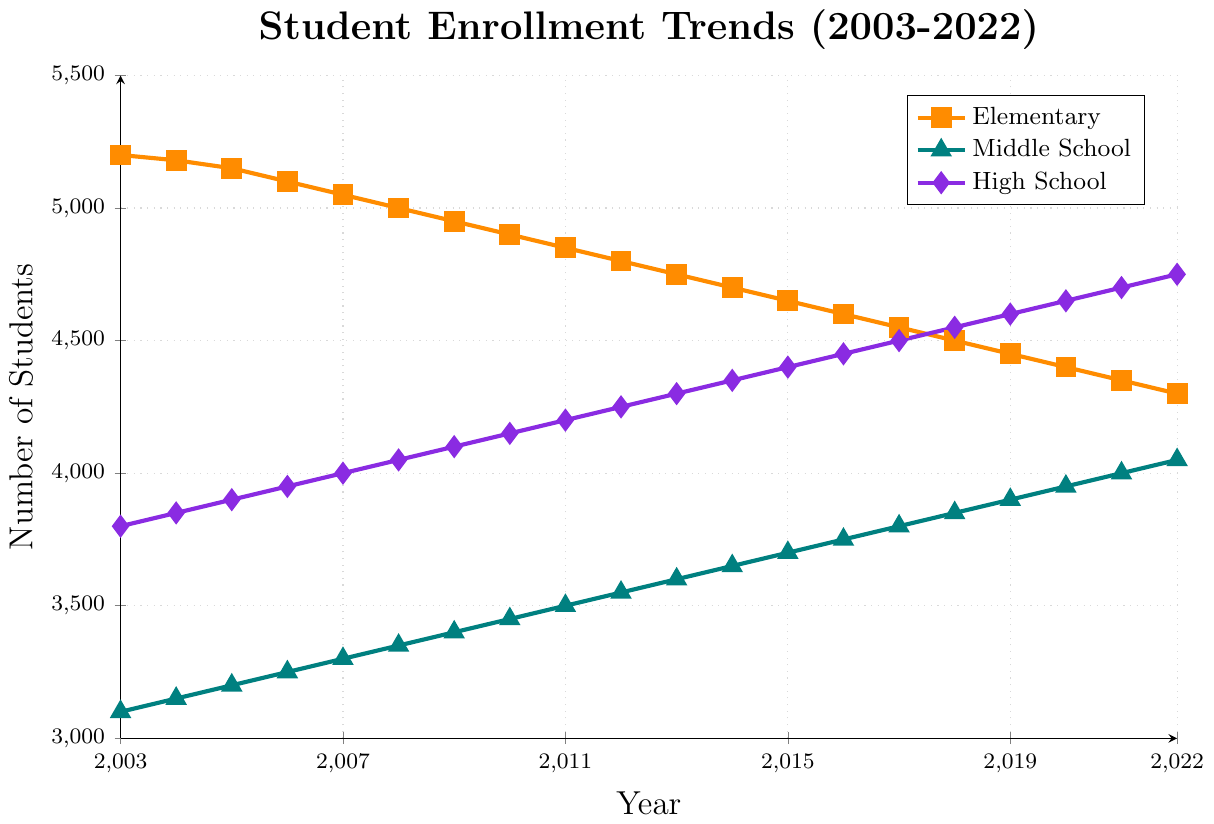What is the trend in elementary school enrollment from 2003 to 2022? The trend is a gradual decline. In 2003, the enrollment was 5200, and in 2022, it decreased to 4300. Observing the figure, we see the line slightly slopes downward over time.
Answer: Gradual decline How does middle school enrollment in 2022 compare to that of 2003? In 2003, middle school enrollment was 3100, and in 2022, it increased to 4050. We can see from the figure that the line for middle school enrollment trends upwards.
Answer: Increased by 950 Which grade level shows the most significant increase over the 20-year period? By comparing the slopes of the lines, the high school enrollment shows the most significant increase. It starts at 3800 in 2003 and ends at 4750 in 2022.
Answer: High School In which year did elementary school enrollment drop below 5000? From the visual data, elementary school enrollment dropped below 5000 around 2008.
Answer: 2008 By how much did high school enrollment increase between 2003 and 2022? The enrollment for high school was 3800 in 2003 and 4750 in 2022. The increase is 4750 - 3800.
Answer: Increased by 950 Compare the enrollment trend for middle school and high school from 2010 to 2022. Both trends show an increase, but the high school shows a sharper increase. Middle school enrollment went from 3450 to 4050, and high school went from 4150 to 4750.
Answer: Both increased; High School more sharply When did the middle school enrollment first reach 4000? By observing the middle school enrollment line, it first reached 4000 in 2021.
Answer: 2021 How much did the elementary school enrollment decrease from 2009 to 2022? In 2009, elementary school enrollment was 4950, and in 2022, it was 4300. The decrease is 4950 - 4300.
Answer: Decreased by 650 Which grade level had the smallest change in enrollment over the 20-year period? By visually comparing the trends, elementary school shows a consistent decrease, middle school a moderate increase, and high school a significant increase. The middle school had the smallest change in the slope.
Answer: Middle School 